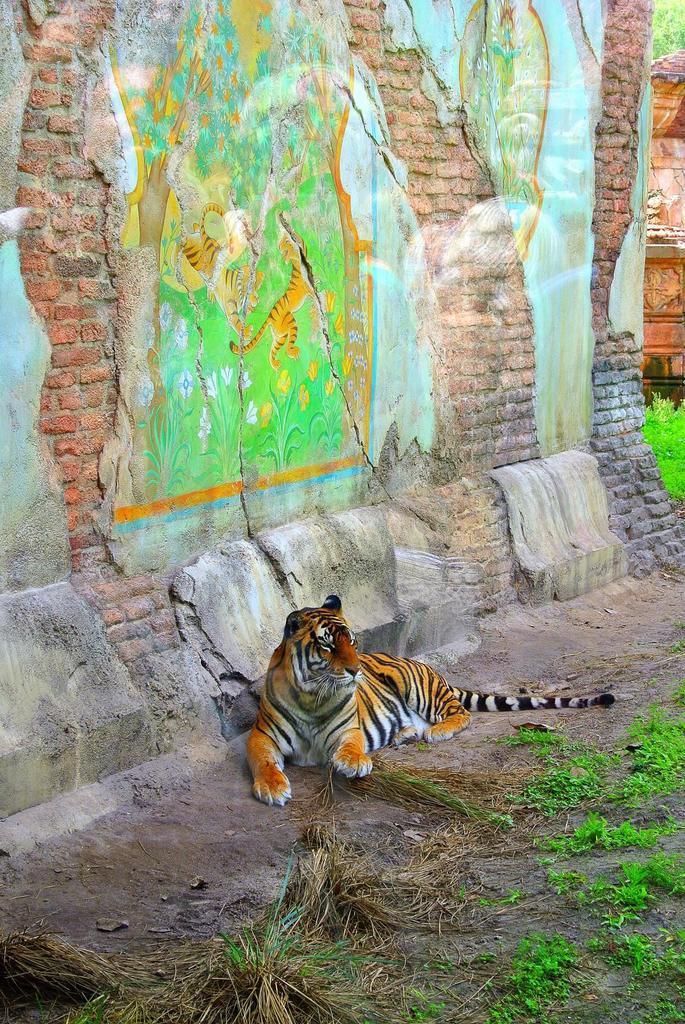Can you describe this image briefly? In this image we can see a tiger is sitting. Behind one brick wall is there. On land some grass is present. 